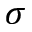<formula> <loc_0><loc_0><loc_500><loc_500>\sigma</formula> 